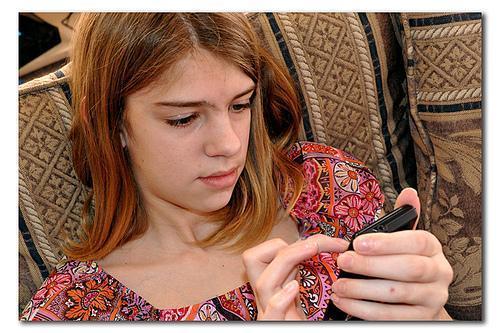How many girls are are there in the photo?
Give a very brief answer. 1. 